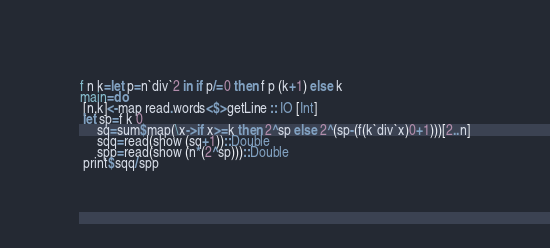Convert code to text. <code><loc_0><loc_0><loc_500><loc_500><_Haskell_>f n k=let p=n`div`2 in if p/=0 then f p (k+1) else k
main=do
 [n,k]<-map read.words<$>getLine :: IO [Int]
 let sp=f k 0
     sq=sum$map(\x->if x>=k then 2^sp else 2^(sp-(f(k`div`x)0+1)))[2..n]
     sqq=read(show (sq+1))::Double
     spp=read(show (n*(2^sp)))::Double
 print$sqq/spp</code> 